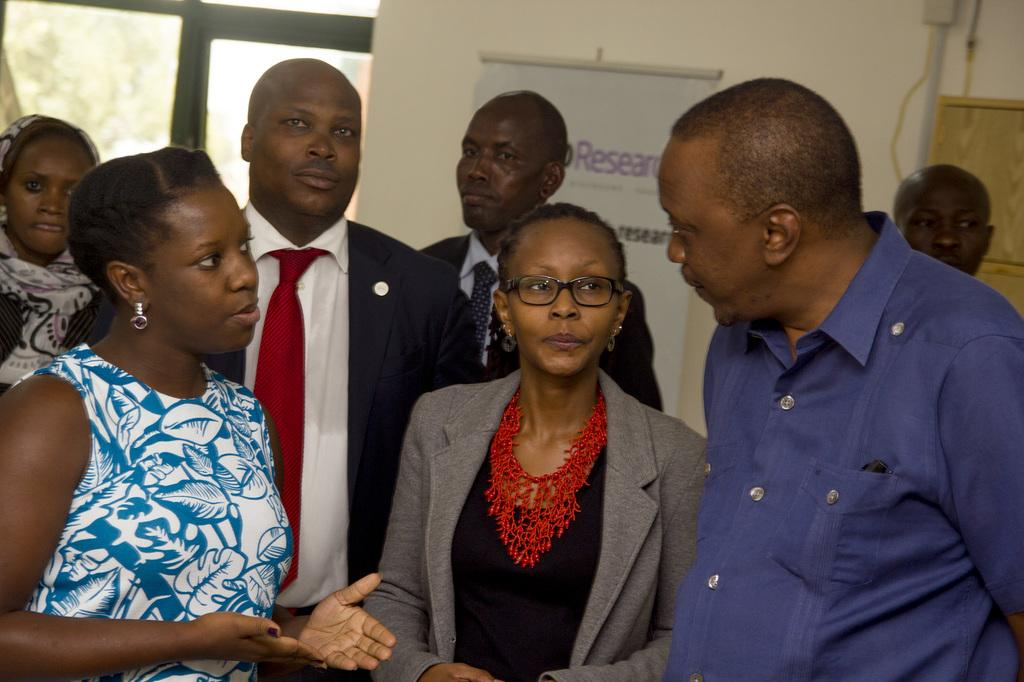How many people are in the image? There is a group of people in the image. What are the people in the image doing? The people are standing. What can be seen in the image besides the people? There is a banner in the image. What is visible in the background of the image? There is a wall in the background of the image. What time is displayed on the clock in the image? There is no clock present in the image. How many rings are visible on the people's fingers in the image? There are no rings visible on the people's fingers in the image. 